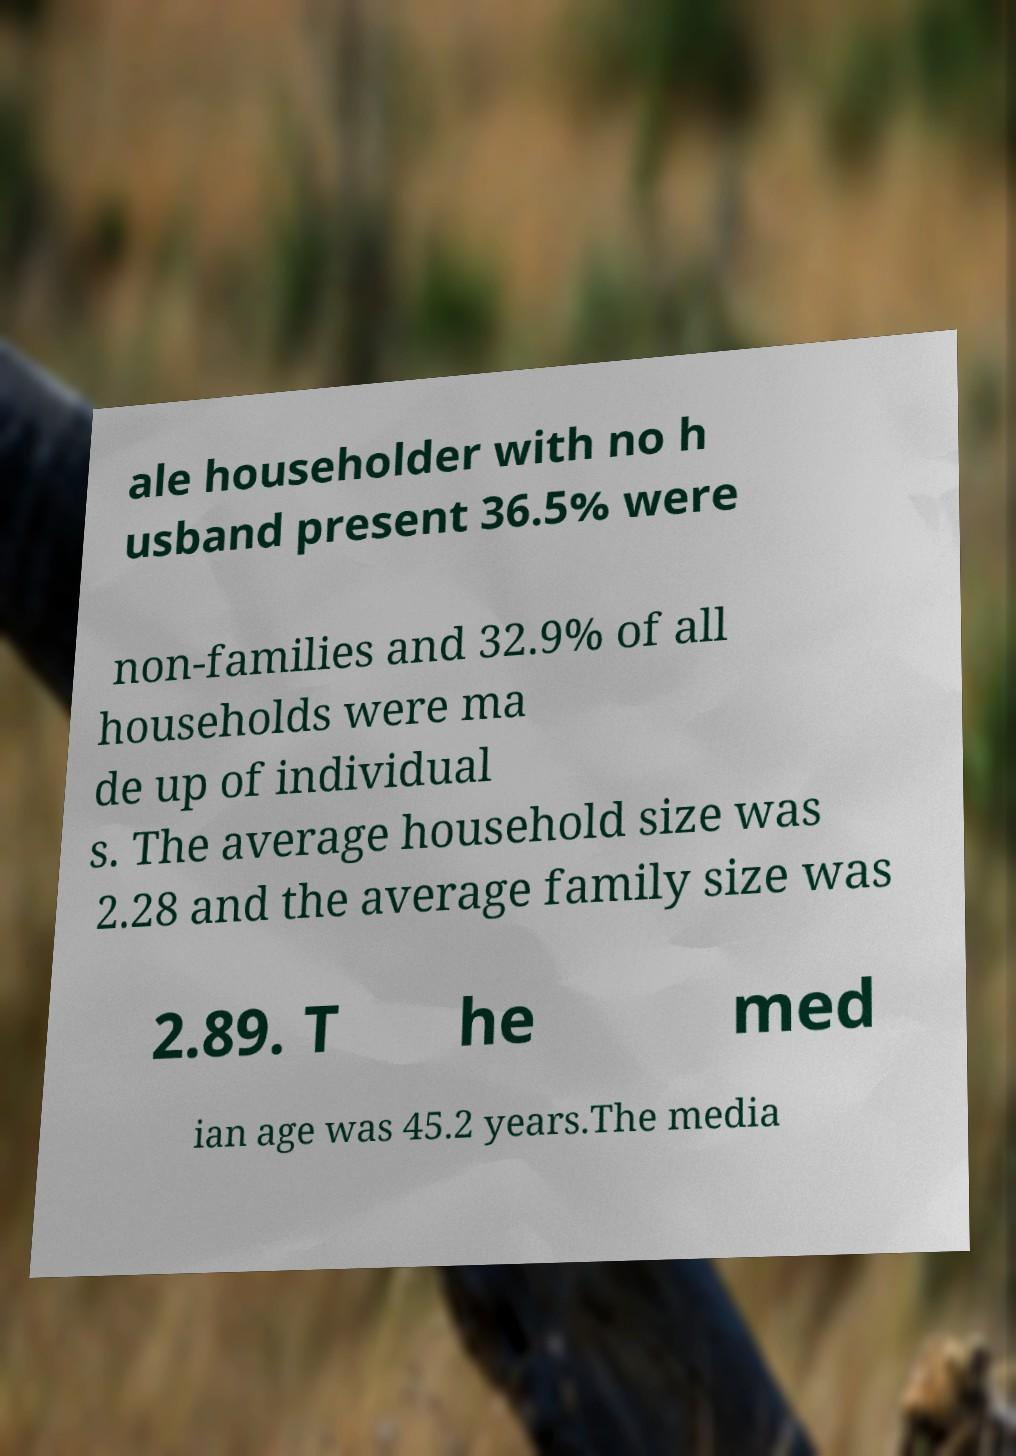What messages or text are displayed in this image? I need them in a readable, typed format. ale householder with no h usband present 36.5% were non-families and 32.9% of all households were ma de up of individual s. The average household size was 2.28 and the average family size was 2.89. T he med ian age was 45.2 years.The media 